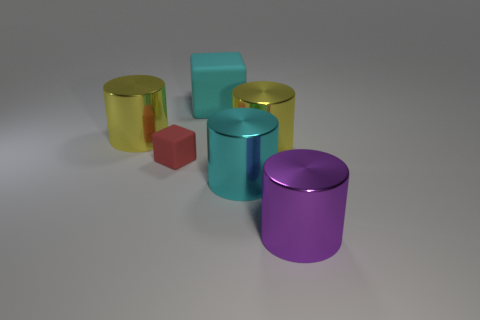Are there any cyan objects that have the same shape as the tiny red matte thing? Yes, there is a cyan cylinder that matches the shape of the tiny red cube. 